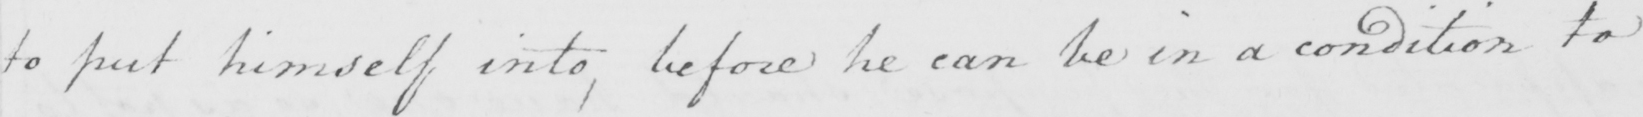Please transcribe the handwritten text in this image. to put himself into, before he can be in a condition to 